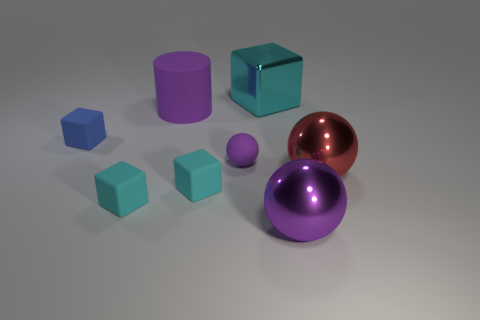Subtract all large red metallic spheres. How many spheres are left? 2 Add 1 big shiny balls. How many objects exist? 9 Subtract all green blocks. How many purple spheres are left? 2 Subtract all purple spheres. How many spheres are left? 1 Subtract all spheres. How many objects are left? 5 Subtract 0 brown blocks. How many objects are left? 8 Subtract 2 spheres. How many spheres are left? 1 Subtract all cyan cubes. Subtract all gray cylinders. How many cubes are left? 1 Subtract all large blocks. Subtract all cyan shiny objects. How many objects are left? 6 Add 2 purple metal objects. How many purple metal objects are left? 3 